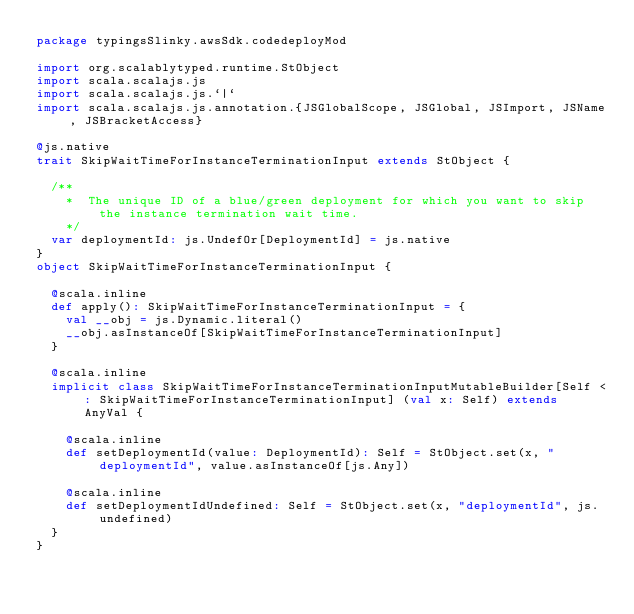Convert code to text. <code><loc_0><loc_0><loc_500><loc_500><_Scala_>package typingsSlinky.awsSdk.codedeployMod

import org.scalablytyped.runtime.StObject
import scala.scalajs.js
import scala.scalajs.js.`|`
import scala.scalajs.js.annotation.{JSGlobalScope, JSGlobal, JSImport, JSName, JSBracketAccess}

@js.native
trait SkipWaitTimeForInstanceTerminationInput extends StObject {
  
  /**
    *  The unique ID of a blue/green deployment for which you want to skip the instance termination wait time. 
    */
  var deploymentId: js.UndefOr[DeploymentId] = js.native
}
object SkipWaitTimeForInstanceTerminationInput {
  
  @scala.inline
  def apply(): SkipWaitTimeForInstanceTerminationInput = {
    val __obj = js.Dynamic.literal()
    __obj.asInstanceOf[SkipWaitTimeForInstanceTerminationInput]
  }
  
  @scala.inline
  implicit class SkipWaitTimeForInstanceTerminationInputMutableBuilder[Self <: SkipWaitTimeForInstanceTerminationInput] (val x: Self) extends AnyVal {
    
    @scala.inline
    def setDeploymentId(value: DeploymentId): Self = StObject.set(x, "deploymentId", value.asInstanceOf[js.Any])
    
    @scala.inline
    def setDeploymentIdUndefined: Self = StObject.set(x, "deploymentId", js.undefined)
  }
}
</code> 